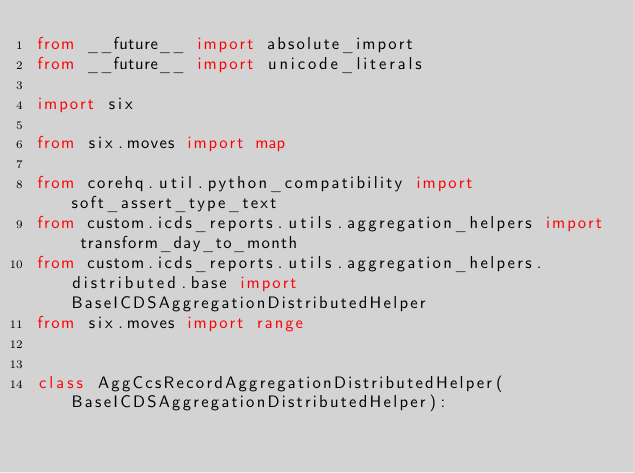<code> <loc_0><loc_0><loc_500><loc_500><_Python_>from __future__ import absolute_import
from __future__ import unicode_literals

import six

from six.moves import map

from corehq.util.python_compatibility import soft_assert_type_text
from custom.icds_reports.utils.aggregation_helpers import transform_day_to_month
from custom.icds_reports.utils.aggregation_helpers.distributed.base import BaseICDSAggregationDistributedHelper
from six.moves import range


class AggCcsRecordAggregationDistributedHelper(BaseICDSAggregationDistributedHelper):</code> 